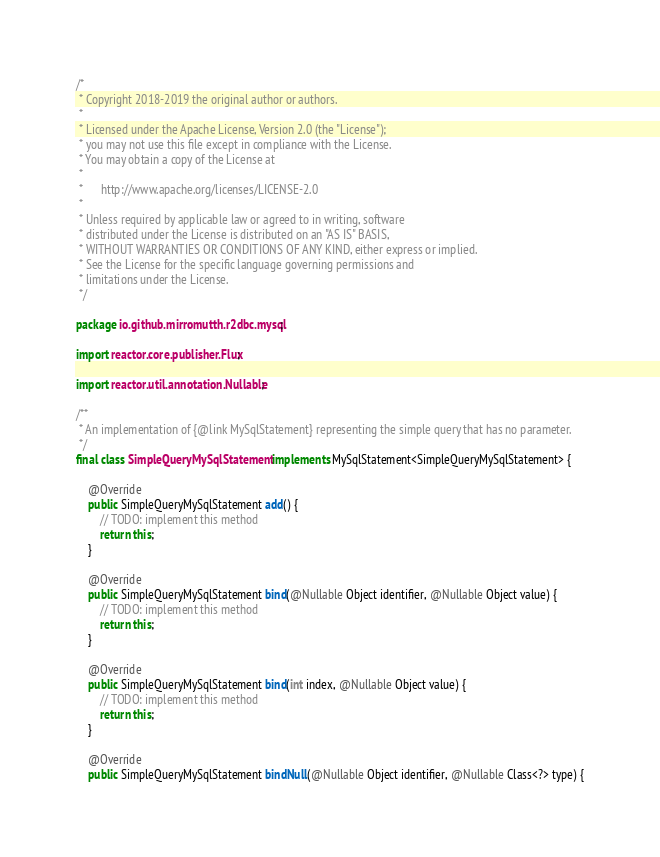Convert code to text. <code><loc_0><loc_0><loc_500><loc_500><_Java_>/*
 * Copyright 2018-2019 the original author or authors.
 *
 * Licensed under the Apache License, Version 2.0 (the "License");
 * you may not use this file except in compliance with the License.
 * You may obtain a copy of the License at
 *
 *      http://www.apache.org/licenses/LICENSE-2.0
 *
 * Unless required by applicable law or agreed to in writing, software
 * distributed under the License is distributed on an "AS IS" BASIS,
 * WITHOUT WARRANTIES OR CONDITIONS OF ANY KIND, either express or implied.
 * See the License for the specific language governing permissions and
 * limitations under the License.
 */

package io.github.mirromutth.r2dbc.mysql;

import reactor.core.publisher.Flux;

import reactor.util.annotation.Nullable;

/**
 * An implementation of {@link MySqlStatement} representing the simple query that has no parameter.
 */
final class SimpleQueryMySqlStatement implements MySqlStatement<SimpleQueryMySqlStatement> {

    @Override
    public SimpleQueryMySqlStatement add() {
        // TODO: implement this method
        return this;
    }

    @Override
    public SimpleQueryMySqlStatement bind(@Nullable Object identifier, @Nullable Object value) {
        // TODO: implement this method
        return this;
    }

    @Override
    public SimpleQueryMySqlStatement bind(int index, @Nullable Object value) {
        // TODO: implement this method
        return this;
    }

    @Override
    public SimpleQueryMySqlStatement bindNull(@Nullable Object identifier, @Nullable Class<?> type) {</code> 